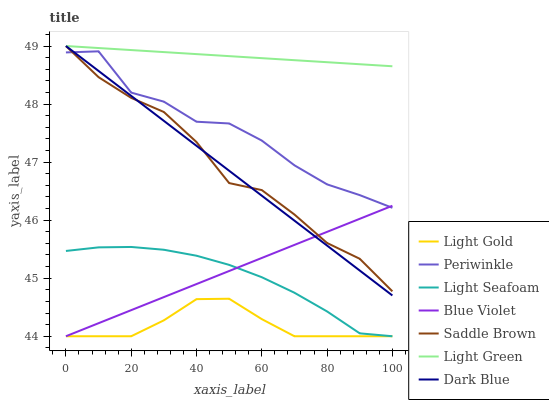Does Light Gold have the minimum area under the curve?
Answer yes or no. Yes. Does Light Green have the maximum area under the curve?
Answer yes or no. Yes. Does Periwinkle have the minimum area under the curve?
Answer yes or no. No. Does Periwinkle have the maximum area under the curve?
Answer yes or no. No. Is Dark Blue the smoothest?
Answer yes or no. Yes. Is Periwinkle the roughest?
Answer yes or no. Yes. Is Light Green the smoothest?
Answer yes or no. No. Is Light Green the roughest?
Answer yes or no. No. Does Periwinkle have the lowest value?
Answer yes or no. No. Does Saddle Brown have the highest value?
Answer yes or no. Yes. Does Periwinkle have the highest value?
Answer yes or no. No. Is Light Gold less than Periwinkle?
Answer yes or no. Yes. Is Light Green greater than Light Gold?
Answer yes or no. Yes. Does Blue Violet intersect Dark Blue?
Answer yes or no. Yes. Is Blue Violet less than Dark Blue?
Answer yes or no. No. Is Blue Violet greater than Dark Blue?
Answer yes or no. No. Does Light Gold intersect Periwinkle?
Answer yes or no. No. 